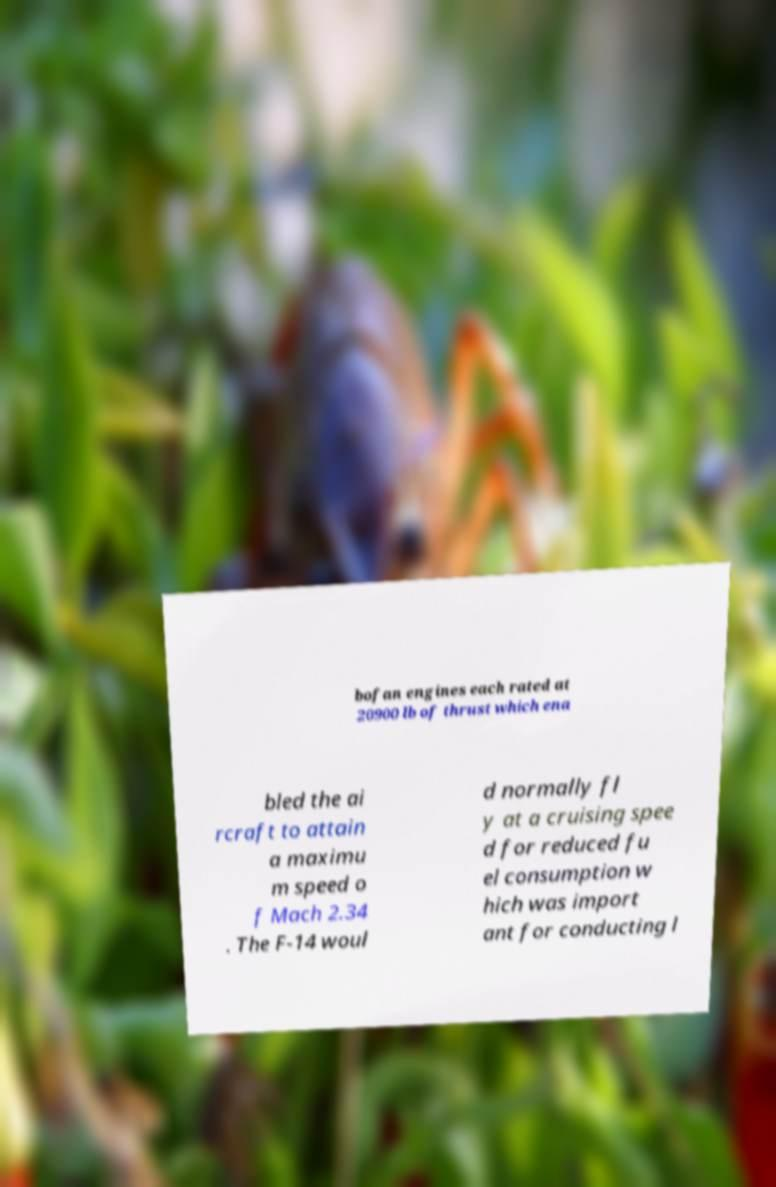Please read and relay the text visible in this image. What does it say? bofan engines each rated at 20900 lb of thrust which ena bled the ai rcraft to attain a maximu m speed o f Mach 2.34 . The F-14 woul d normally fl y at a cruising spee d for reduced fu el consumption w hich was import ant for conducting l 